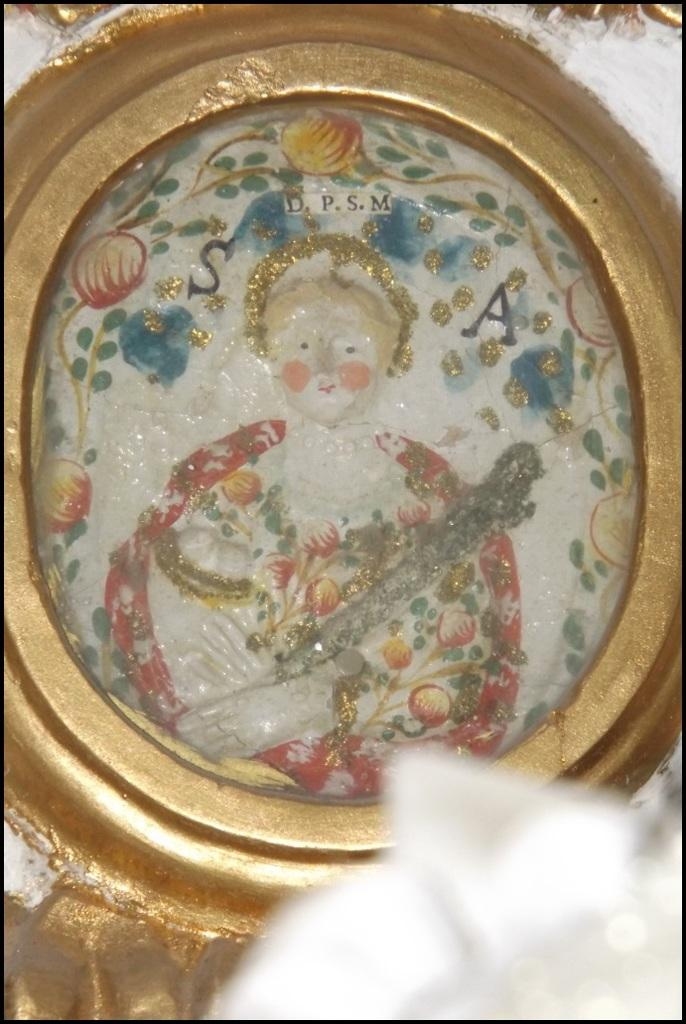What is present on the wall in the image? There is a painting and carvings on the wall in the image. Can you describe the painting on the wall? Unfortunately, the facts provided do not give a description of the painting. What type of decorations are present on the wall? The wall has a painting and carvings on it. How many lumberjacks can be seen in the image? There is no reference to lumberjacks in the image, so it is not possible to determine how many might be present. 